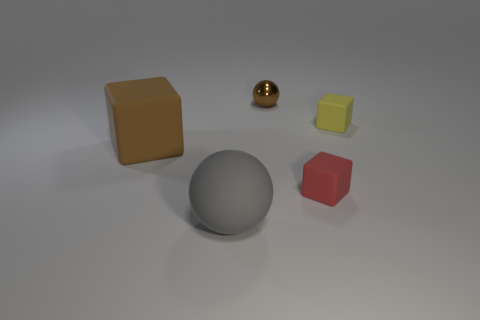What number of large purple metal blocks are there?
Keep it short and to the point. 0. What is the shape of the tiny red thing that is made of the same material as the gray ball?
Offer a terse response. Cube. There is a sphere that is in front of the rubber object to the left of the gray object; how big is it?
Give a very brief answer. Large. What number of things are either objects that are behind the large gray matte object or things behind the red matte object?
Offer a terse response. 4. Is the number of big brown matte blocks less than the number of tiny purple blocks?
Your answer should be very brief. No. How many objects are balls or tiny balls?
Offer a very short reply. 2. Do the red matte object and the big brown rubber thing have the same shape?
Provide a succinct answer. Yes. Is there any other thing that has the same material as the big ball?
Make the answer very short. Yes. Does the sphere that is behind the small red rubber cube have the same size as the object that is on the left side of the big gray rubber sphere?
Keep it short and to the point. No. The object that is both right of the large gray matte ball and left of the small red thing is made of what material?
Make the answer very short. Metal. 